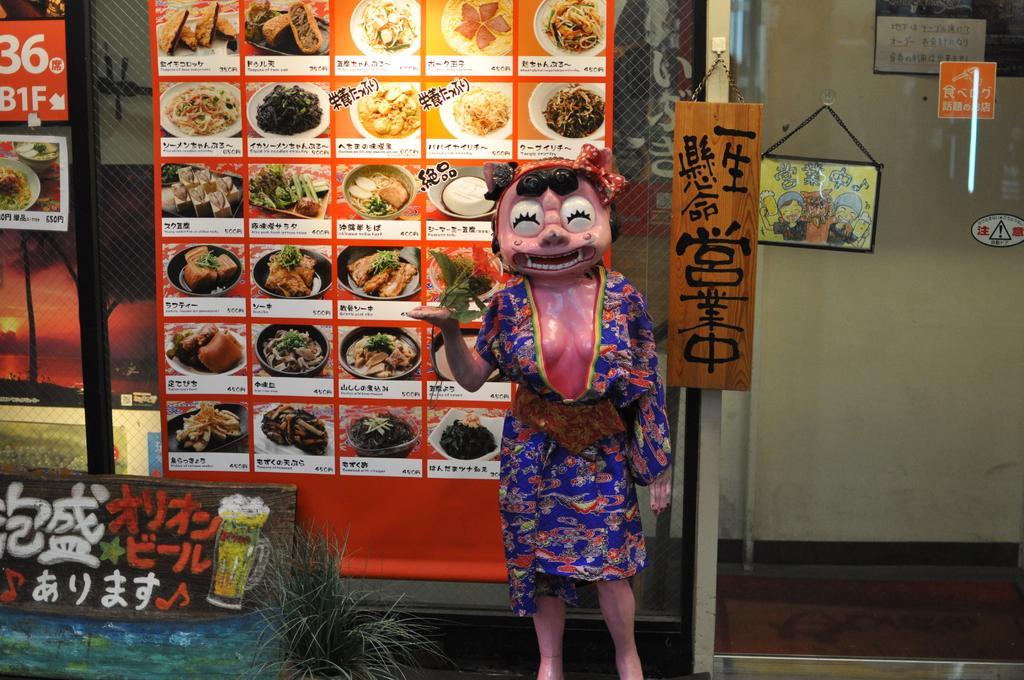Please provide a concise description of this image. In this picture we can see some grass, a text and numbers are visible on the boards. We can see some food items on the poster. There are meshes, glass objects, other objects and a wall is visible in the background. 